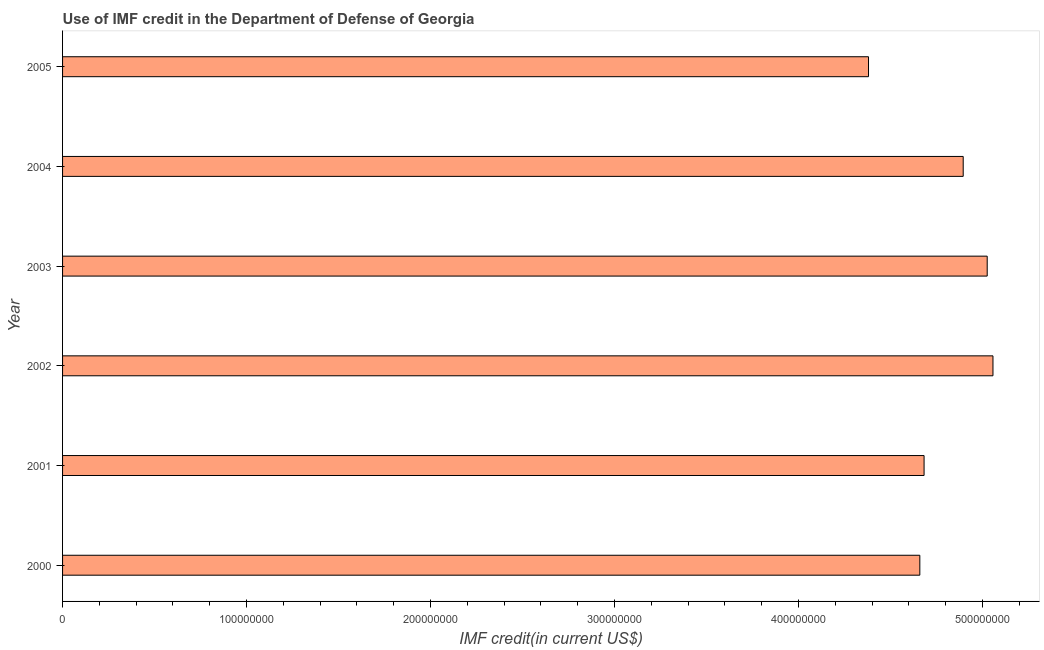Does the graph contain grids?
Give a very brief answer. No. What is the title of the graph?
Make the answer very short. Use of IMF credit in the Department of Defense of Georgia. What is the label or title of the X-axis?
Provide a short and direct response. IMF credit(in current US$). What is the label or title of the Y-axis?
Your answer should be very brief. Year. What is the use of imf credit in dod in 2002?
Give a very brief answer. 5.06e+08. Across all years, what is the maximum use of imf credit in dod?
Your answer should be very brief. 5.06e+08. Across all years, what is the minimum use of imf credit in dod?
Your response must be concise. 4.38e+08. In which year was the use of imf credit in dod minimum?
Your answer should be very brief. 2005. What is the sum of the use of imf credit in dod?
Your answer should be very brief. 2.87e+09. What is the difference between the use of imf credit in dod in 2000 and 2001?
Give a very brief answer. -2.30e+06. What is the average use of imf credit in dod per year?
Your answer should be compact. 4.78e+08. What is the median use of imf credit in dod?
Provide a succinct answer. 4.79e+08. In how many years, is the use of imf credit in dod greater than 400000000 US$?
Offer a very short reply. 6. Do a majority of the years between 2003 and 2004 (inclusive) have use of imf credit in dod greater than 160000000 US$?
Give a very brief answer. Yes. What is the ratio of the use of imf credit in dod in 2001 to that in 2003?
Offer a terse response. 0.93. Is the use of imf credit in dod in 2001 less than that in 2004?
Make the answer very short. Yes. Is the difference between the use of imf credit in dod in 2000 and 2003 greater than the difference between any two years?
Offer a very short reply. No. What is the difference between the highest and the second highest use of imf credit in dod?
Ensure brevity in your answer.  3.13e+06. What is the difference between the highest and the lowest use of imf credit in dod?
Give a very brief answer. 6.76e+07. In how many years, is the use of imf credit in dod greater than the average use of imf credit in dod taken over all years?
Your response must be concise. 3. What is the difference between two consecutive major ticks on the X-axis?
Offer a terse response. 1.00e+08. Are the values on the major ticks of X-axis written in scientific E-notation?
Offer a terse response. No. What is the IMF credit(in current US$) of 2000?
Make the answer very short. 4.66e+08. What is the IMF credit(in current US$) in 2001?
Your response must be concise. 4.68e+08. What is the IMF credit(in current US$) in 2002?
Your response must be concise. 5.06e+08. What is the IMF credit(in current US$) of 2003?
Provide a short and direct response. 5.03e+08. What is the IMF credit(in current US$) of 2004?
Ensure brevity in your answer.  4.90e+08. What is the IMF credit(in current US$) in 2005?
Give a very brief answer. 4.38e+08. What is the difference between the IMF credit(in current US$) in 2000 and 2001?
Your answer should be very brief. -2.30e+06. What is the difference between the IMF credit(in current US$) in 2000 and 2002?
Give a very brief answer. -3.98e+07. What is the difference between the IMF credit(in current US$) in 2000 and 2003?
Ensure brevity in your answer.  -3.66e+07. What is the difference between the IMF credit(in current US$) in 2000 and 2004?
Provide a short and direct response. -2.36e+07. What is the difference between the IMF credit(in current US$) in 2000 and 2005?
Offer a terse response. 2.79e+07. What is the difference between the IMF credit(in current US$) in 2001 and 2002?
Provide a succinct answer. -3.75e+07. What is the difference between the IMF credit(in current US$) in 2001 and 2003?
Keep it short and to the point. -3.43e+07. What is the difference between the IMF credit(in current US$) in 2001 and 2004?
Ensure brevity in your answer.  -2.13e+07. What is the difference between the IMF credit(in current US$) in 2001 and 2005?
Offer a very short reply. 3.02e+07. What is the difference between the IMF credit(in current US$) in 2002 and 2003?
Your answer should be very brief. 3.13e+06. What is the difference between the IMF credit(in current US$) in 2002 and 2004?
Keep it short and to the point. 1.62e+07. What is the difference between the IMF credit(in current US$) in 2002 and 2005?
Provide a short and direct response. 6.76e+07. What is the difference between the IMF credit(in current US$) in 2003 and 2004?
Give a very brief answer. 1.30e+07. What is the difference between the IMF credit(in current US$) in 2003 and 2005?
Provide a succinct answer. 6.45e+07. What is the difference between the IMF credit(in current US$) in 2004 and 2005?
Offer a very short reply. 5.15e+07. What is the ratio of the IMF credit(in current US$) in 2000 to that in 2002?
Your answer should be compact. 0.92. What is the ratio of the IMF credit(in current US$) in 2000 to that in 2003?
Provide a short and direct response. 0.93. What is the ratio of the IMF credit(in current US$) in 2000 to that in 2005?
Your answer should be compact. 1.06. What is the ratio of the IMF credit(in current US$) in 2001 to that in 2002?
Make the answer very short. 0.93. What is the ratio of the IMF credit(in current US$) in 2001 to that in 2003?
Give a very brief answer. 0.93. What is the ratio of the IMF credit(in current US$) in 2001 to that in 2005?
Your response must be concise. 1.07. What is the ratio of the IMF credit(in current US$) in 2002 to that in 2004?
Your response must be concise. 1.03. What is the ratio of the IMF credit(in current US$) in 2002 to that in 2005?
Ensure brevity in your answer.  1.15. What is the ratio of the IMF credit(in current US$) in 2003 to that in 2005?
Give a very brief answer. 1.15. What is the ratio of the IMF credit(in current US$) in 2004 to that in 2005?
Give a very brief answer. 1.12. 